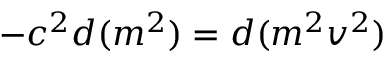<formula> <loc_0><loc_0><loc_500><loc_500>- c ^ { 2 } d ( m ^ { 2 } ) = d ( m ^ { 2 } v ^ { 2 } )</formula> 